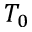<formula> <loc_0><loc_0><loc_500><loc_500>T _ { 0 }</formula> 